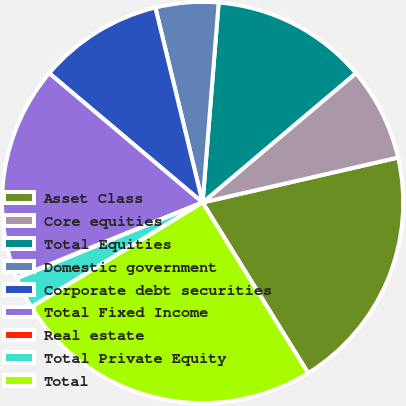Convert chart to OTSL. <chart><loc_0><loc_0><loc_500><loc_500><pie_chart><fcel>Asset Class<fcel>Core equities<fcel>Total Equities<fcel>Domestic government<fcel>Corporate debt securities<fcel>Total Fixed Income<fcel>Real estate<fcel>Total Private Equity<fcel>Total<nl><fcel>19.78%<fcel>7.56%<fcel>12.57%<fcel>5.06%<fcel>10.07%<fcel>17.27%<fcel>0.05%<fcel>2.55%<fcel>25.1%<nl></chart> 